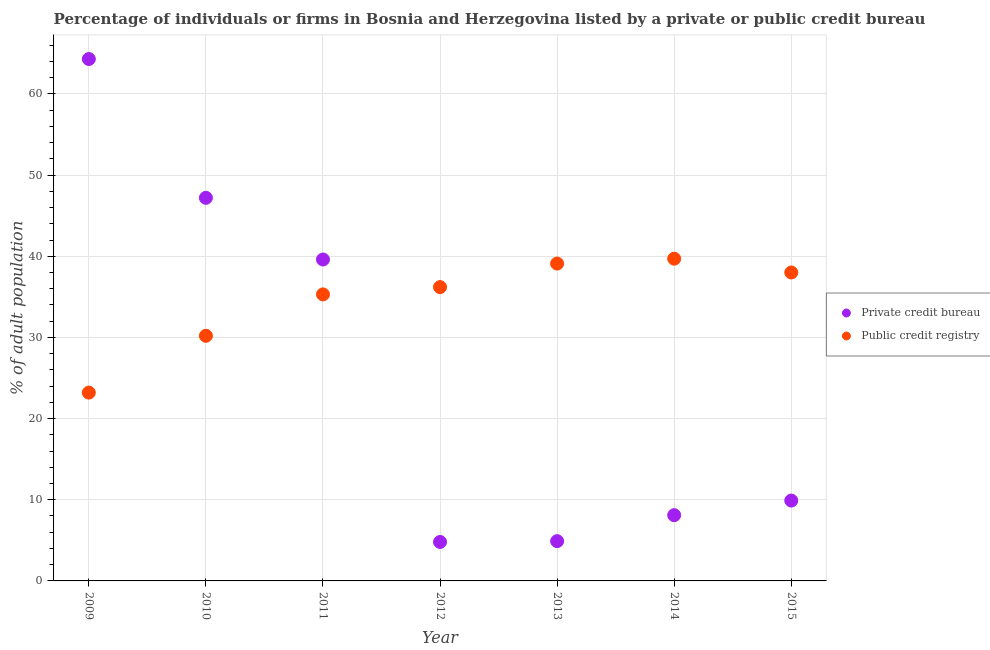How many different coloured dotlines are there?
Provide a short and direct response. 2. What is the percentage of firms listed by public credit bureau in 2009?
Give a very brief answer. 23.2. Across all years, what is the maximum percentage of firms listed by public credit bureau?
Your answer should be compact. 39.7. Across all years, what is the minimum percentage of firms listed by public credit bureau?
Your answer should be very brief. 23.2. In which year was the percentage of firms listed by public credit bureau maximum?
Your response must be concise. 2014. What is the total percentage of firms listed by private credit bureau in the graph?
Your response must be concise. 178.8. What is the difference between the percentage of firms listed by private credit bureau in 2009 and that in 2015?
Your response must be concise. 54.4. What is the difference between the percentage of firms listed by public credit bureau in 2013 and the percentage of firms listed by private credit bureau in 2009?
Your answer should be compact. -25.2. What is the average percentage of firms listed by private credit bureau per year?
Your response must be concise. 25.54. In the year 2012, what is the difference between the percentage of firms listed by public credit bureau and percentage of firms listed by private credit bureau?
Give a very brief answer. 31.4. In how many years, is the percentage of firms listed by public credit bureau greater than 34 %?
Keep it short and to the point. 5. What is the ratio of the percentage of firms listed by public credit bureau in 2010 to that in 2012?
Your answer should be very brief. 0.83. Is the percentage of firms listed by public credit bureau in 2011 less than that in 2015?
Ensure brevity in your answer.  Yes. What is the difference between the highest and the second highest percentage of firms listed by private credit bureau?
Provide a succinct answer. 17.1. What is the difference between the highest and the lowest percentage of firms listed by public credit bureau?
Offer a very short reply. 16.5. Is the sum of the percentage of firms listed by public credit bureau in 2011 and 2012 greater than the maximum percentage of firms listed by private credit bureau across all years?
Your answer should be very brief. Yes. Does the percentage of firms listed by public credit bureau monotonically increase over the years?
Make the answer very short. No. Is the percentage of firms listed by private credit bureau strictly greater than the percentage of firms listed by public credit bureau over the years?
Offer a very short reply. No. How many years are there in the graph?
Your answer should be compact. 7. What is the difference between two consecutive major ticks on the Y-axis?
Ensure brevity in your answer.  10. Are the values on the major ticks of Y-axis written in scientific E-notation?
Provide a succinct answer. No. Does the graph contain any zero values?
Ensure brevity in your answer.  No. How are the legend labels stacked?
Provide a succinct answer. Vertical. What is the title of the graph?
Ensure brevity in your answer.  Percentage of individuals or firms in Bosnia and Herzegovina listed by a private or public credit bureau. Does "Canada" appear as one of the legend labels in the graph?
Your response must be concise. No. What is the label or title of the X-axis?
Your answer should be compact. Year. What is the label or title of the Y-axis?
Keep it short and to the point. % of adult population. What is the % of adult population in Private credit bureau in 2009?
Give a very brief answer. 64.3. What is the % of adult population in Public credit registry in 2009?
Your response must be concise. 23.2. What is the % of adult population in Private credit bureau in 2010?
Make the answer very short. 47.2. What is the % of adult population of Public credit registry in 2010?
Make the answer very short. 30.2. What is the % of adult population of Private credit bureau in 2011?
Make the answer very short. 39.6. What is the % of adult population in Public credit registry in 2011?
Your response must be concise. 35.3. What is the % of adult population of Public credit registry in 2012?
Offer a very short reply. 36.2. What is the % of adult population of Public credit registry in 2013?
Give a very brief answer. 39.1. What is the % of adult population of Private credit bureau in 2014?
Give a very brief answer. 8.1. What is the % of adult population in Public credit registry in 2014?
Offer a terse response. 39.7. What is the % of adult population in Private credit bureau in 2015?
Your answer should be very brief. 9.9. What is the % of adult population of Public credit registry in 2015?
Your response must be concise. 38. Across all years, what is the maximum % of adult population of Private credit bureau?
Keep it short and to the point. 64.3. Across all years, what is the maximum % of adult population of Public credit registry?
Keep it short and to the point. 39.7. Across all years, what is the minimum % of adult population of Public credit registry?
Your response must be concise. 23.2. What is the total % of adult population in Private credit bureau in the graph?
Ensure brevity in your answer.  178.8. What is the total % of adult population of Public credit registry in the graph?
Make the answer very short. 241.7. What is the difference between the % of adult population in Public credit registry in 2009 and that in 2010?
Your answer should be compact. -7. What is the difference between the % of adult population of Private credit bureau in 2009 and that in 2011?
Provide a short and direct response. 24.7. What is the difference between the % of adult population of Private credit bureau in 2009 and that in 2012?
Offer a terse response. 59.5. What is the difference between the % of adult population in Private credit bureau in 2009 and that in 2013?
Make the answer very short. 59.4. What is the difference between the % of adult population in Public credit registry in 2009 and that in 2013?
Give a very brief answer. -15.9. What is the difference between the % of adult population in Private credit bureau in 2009 and that in 2014?
Make the answer very short. 56.2. What is the difference between the % of adult population of Public credit registry in 2009 and that in 2014?
Offer a terse response. -16.5. What is the difference between the % of adult population of Private credit bureau in 2009 and that in 2015?
Offer a terse response. 54.4. What is the difference between the % of adult population in Public credit registry in 2009 and that in 2015?
Provide a succinct answer. -14.8. What is the difference between the % of adult population of Public credit registry in 2010 and that in 2011?
Offer a very short reply. -5.1. What is the difference between the % of adult population in Private credit bureau in 2010 and that in 2012?
Provide a succinct answer. 42.4. What is the difference between the % of adult population in Private credit bureau in 2010 and that in 2013?
Make the answer very short. 42.3. What is the difference between the % of adult population in Private credit bureau in 2010 and that in 2014?
Ensure brevity in your answer.  39.1. What is the difference between the % of adult population in Public credit registry in 2010 and that in 2014?
Make the answer very short. -9.5. What is the difference between the % of adult population of Private credit bureau in 2010 and that in 2015?
Give a very brief answer. 37.3. What is the difference between the % of adult population in Private credit bureau in 2011 and that in 2012?
Your answer should be compact. 34.8. What is the difference between the % of adult population in Public credit registry in 2011 and that in 2012?
Give a very brief answer. -0.9. What is the difference between the % of adult population in Private credit bureau in 2011 and that in 2013?
Your answer should be compact. 34.7. What is the difference between the % of adult population in Private credit bureau in 2011 and that in 2014?
Your response must be concise. 31.5. What is the difference between the % of adult population in Public credit registry in 2011 and that in 2014?
Provide a succinct answer. -4.4. What is the difference between the % of adult population of Private credit bureau in 2011 and that in 2015?
Give a very brief answer. 29.7. What is the difference between the % of adult population of Private credit bureau in 2012 and that in 2014?
Offer a terse response. -3.3. What is the difference between the % of adult population of Public credit registry in 2012 and that in 2015?
Your response must be concise. -1.8. What is the difference between the % of adult population of Private credit bureau in 2013 and that in 2015?
Make the answer very short. -5. What is the difference between the % of adult population in Private credit bureau in 2009 and the % of adult population in Public credit registry in 2010?
Offer a terse response. 34.1. What is the difference between the % of adult population in Private credit bureau in 2009 and the % of adult population in Public credit registry in 2012?
Give a very brief answer. 28.1. What is the difference between the % of adult population in Private credit bureau in 2009 and the % of adult population in Public credit registry in 2013?
Your response must be concise. 25.2. What is the difference between the % of adult population of Private credit bureau in 2009 and the % of adult population of Public credit registry in 2014?
Provide a short and direct response. 24.6. What is the difference between the % of adult population in Private credit bureau in 2009 and the % of adult population in Public credit registry in 2015?
Your response must be concise. 26.3. What is the difference between the % of adult population of Private credit bureau in 2010 and the % of adult population of Public credit registry in 2011?
Your answer should be very brief. 11.9. What is the difference between the % of adult population in Private credit bureau in 2010 and the % of adult population in Public credit registry in 2013?
Offer a very short reply. 8.1. What is the difference between the % of adult population of Private credit bureau in 2010 and the % of adult population of Public credit registry in 2014?
Your answer should be very brief. 7.5. What is the difference between the % of adult population of Private credit bureau in 2010 and the % of adult population of Public credit registry in 2015?
Your response must be concise. 9.2. What is the difference between the % of adult population in Private credit bureau in 2011 and the % of adult population in Public credit registry in 2013?
Your response must be concise. 0.5. What is the difference between the % of adult population of Private credit bureau in 2011 and the % of adult population of Public credit registry in 2014?
Offer a terse response. -0.1. What is the difference between the % of adult population of Private credit bureau in 2012 and the % of adult population of Public credit registry in 2013?
Provide a short and direct response. -34.3. What is the difference between the % of adult population in Private credit bureau in 2012 and the % of adult population in Public credit registry in 2014?
Ensure brevity in your answer.  -34.9. What is the difference between the % of adult population of Private credit bureau in 2012 and the % of adult population of Public credit registry in 2015?
Your answer should be compact. -33.2. What is the difference between the % of adult population of Private credit bureau in 2013 and the % of adult population of Public credit registry in 2014?
Keep it short and to the point. -34.8. What is the difference between the % of adult population in Private credit bureau in 2013 and the % of adult population in Public credit registry in 2015?
Provide a succinct answer. -33.1. What is the difference between the % of adult population in Private credit bureau in 2014 and the % of adult population in Public credit registry in 2015?
Provide a succinct answer. -29.9. What is the average % of adult population of Private credit bureau per year?
Ensure brevity in your answer.  25.54. What is the average % of adult population of Public credit registry per year?
Your answer should be compact. 34.53. In the year 2009, what is the difference between the % of adult population in Private credit bureau and % of adult population in Public credit registry?
Offer a terse response. 41.1. In the year 2012, what is the difference between the % of adult population in Private credit bureau and % of adult population in Public credit registry?
Give a very brief answer. -31.4. In the year 2013, what is the difference between the % of adult population of Private credit bureau and % of adult population of Public credit registry?
Offer a very short reply. -34.2. In the year 2014, what is the difference between the % of adult population of Private credit bureau and % of adult population of Public credit registry?
Provide a short and direct response. -31.6. In the year 2015, what is the difference between the % of adult population in Private credit bureau and % of adult population in Public credit registry?
Your answer should be very brief. -28.1. What is the ratio of the % of adult population in Private credit bureau in 2009 to that in 2010?
Keep it short and to the point. 1.36. What is the ratio of the % of adult population of Public credit registry in 2009 to that in 2010?
Offer a very short reply. 0.77. What is the ratio of the % of adult population of Private credit bureau in 2009 to that in 2011?
Give a very brief answer. 1.62. What is the ratio of the % of adult population of Public credit registry in 2009 to that in 2011?
Provide a succinct answer. 0.66. What is the ratio of the % of adult population of Private credit bureau in 2009 to that in 2012?
Your answer should be compact. 13.4. What is the ratio of the % of adult population of Public credit registry in 2009 to that in 2012?
Provide a short and direct response. 0.64. What is the ratio of the % of adult population of Private credit bureau in 2009 to that in 2013?
Your answer should be very brief. 13.12. What is the ratio of the % of adult population in Public credit registry in 2009 to that in 2013?
Give a very brief answer. 0.59. What is the ratio of the % of adult population of Private credit bureau in 2009 to that in 2014?
Your answer should be very brief. 7.94. What is the ratio of the % of adult population of Public credit registry in 2009 to that in 2014?
Offer a terse response. 0.58. What is the ratio of the % of adult population of Private credit bureau in 2009 to that in 2015?
Provide a succinct answer. 6.49. What is the ratio of the % of adult population in Public credit registry in 2009 to that in 2015?
Provide a short and direct response. 0.61. What is the ratio of the % of adult population in Private credit bureau in 2010 to that in 2011?
Your response must be concise. 1.19. What is the ratio of the % of adult population in Public credit registry in 2010 to that in 2011?
Offer a terse response. 0.86. What is the ratio of the % of adult population of Private credit bureau in 2010 to that in 2012?
Your answer should be very brief. 9.83. What is the ratio of the % of adult population in Public credit registry in 2010 to that in 2012?
Offer a terse response. 0.83. What is the ratio of the % of adult population in Private credit bureau in 2010 to that in 2013?
Provide a succinct answer. 9.63. What is the ratio of the % of adult population of Public credit registry in 2010 to that in 2013?
Offer a very short reply. 0.77. What is the ratio of the % of adult population of Private credit bureau in 2010 to that in 2014?
Keep it short and to the point. 5.83. What is the ratio of the % of adult population of Public credit registry in 2010 to that in 2014?
Give a very brief answer. 0.76. What is the ratio of the % of adult population in Private credit bureau in 2010 to that in 2015?
Provide a short and direct response. 4.77. What is the ratio of the % of adult population of Public credit registry in 2010 to that in 2015?
Your answer should be very brief. 0.79. What is the ratio of the % of adult population of Private credit bureau in 2011 to that in 2012?
Offer a terse response. 8.25. What is the ratio of the % of adult population of Public credit registry in 2011 to that in 2012?
Ensure brevity in your answer.  0.98. What is the ratio of the % of adult population of Private credit bureau in 2011 to that in 2013?
Ensure brevity in your answer.  8.08. What is the ratio of the % of adult population in Public credit registry in 2011 to that in 2013?
Give a very brief answer. 0.9. What is the ratio of the % of adult population of Private credit bureau in 2011 to that in 2014?
Ensure brevity in your answer.  4.89. What is the ratio of the % of adult population of Public credit registry in 2011 to that in 2014?
Ensure brevity in your answer.  0.89. What is the ratio of the % of adult population in Public credit registry in 2011 to that in 2015?
Provide a succinct answer. 0.93. What is the ratio of the % of adult population of Private credit bureau in 2012 to that in 2013?
Keep it short and to the point. 0.98. What is the ratio of the % of adult population in Public credit registry in 2012 to that in 2013?
Provide a succinct answer. 0.93. What is the ratio of the % of adult population of Private credit bureau in 2012 to that in 2014?
Offer a very short reply. 0.59. What is the ratio of the % of adult population in Public credit registry in 2012 to that in 2014?
Your answer should be very brief. 0.91. What is the ratio of the % of adult population of Private credit bureau in 2012 to that in 2015?
Offer a terse response. 0.48. What is the ratio of the % of adult population of Public credit registry in 2012 to that in 2015?
Give a very brief answer. 0.95. What is the ratio of the % of adult population in Private credit bureau in 2013 to that in 2014?
Keep it short and to the point. 0.6. What is the ratio of the % of adult population of Public credit registry in 2013 to that in 2014?
Your answer should be compact. 0.98. What is the ratio of the % of adult population in Private credit bureau in 2013 to that in 2015?
Make the answer very short. 0.49. What is the ratio of the % of adult population of Public credit registry in 2013 to that in 2015?
Provide a short and direct response. 1.03. What is the ratio of the % of adult population in Private credit bureau in 2014 to that in 2015?
Keep it short and to the point. 0.82. What is the ratio of the % of adult population in Public credit registry in 2014 to that in 2015?
Provide a short and direct response. 1.04. What is the difference between the highest and the lowest % of adult population in Private credit bureau?
Your answer should be compact. 59.5. 